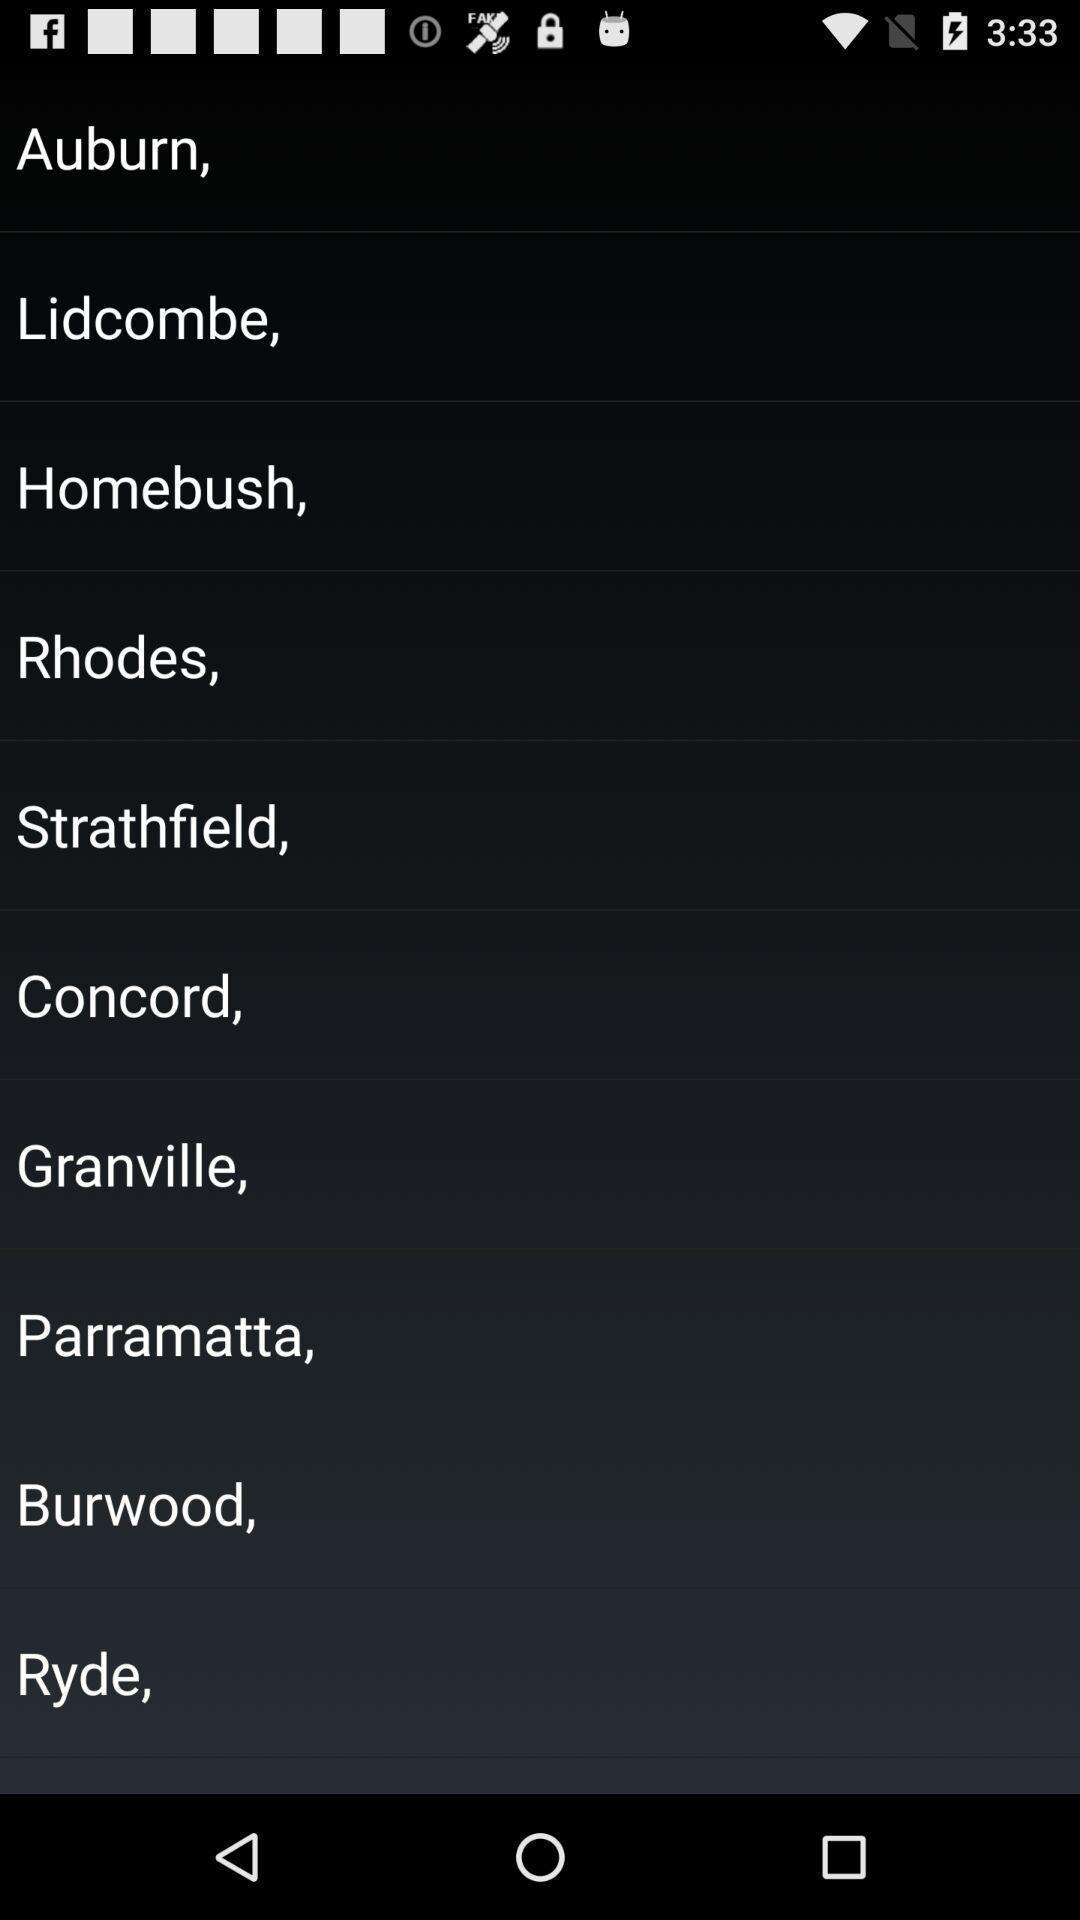Provide a description of this screenshot. Screen displaying the list of cities. 